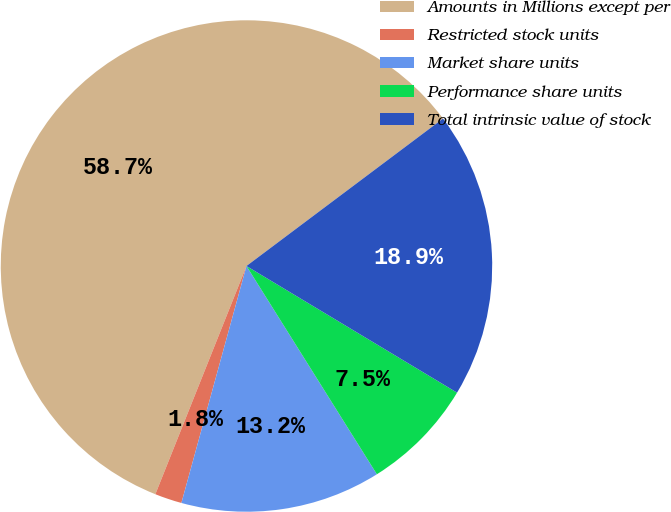<chart> <loc_0><loc_0><loc_500><loc_500><pie_chart><fcel>Amounts in Millions except per<fcel>Restricted stock units<fcel>Market share units<fcel>Performance share units<fcel>Total intrinsic value of stock<nl><fcel>58.71%<fcel>1.78%<fcel>13.17%<fcel>7.48%<fcel>18.86%<nl></chart> 